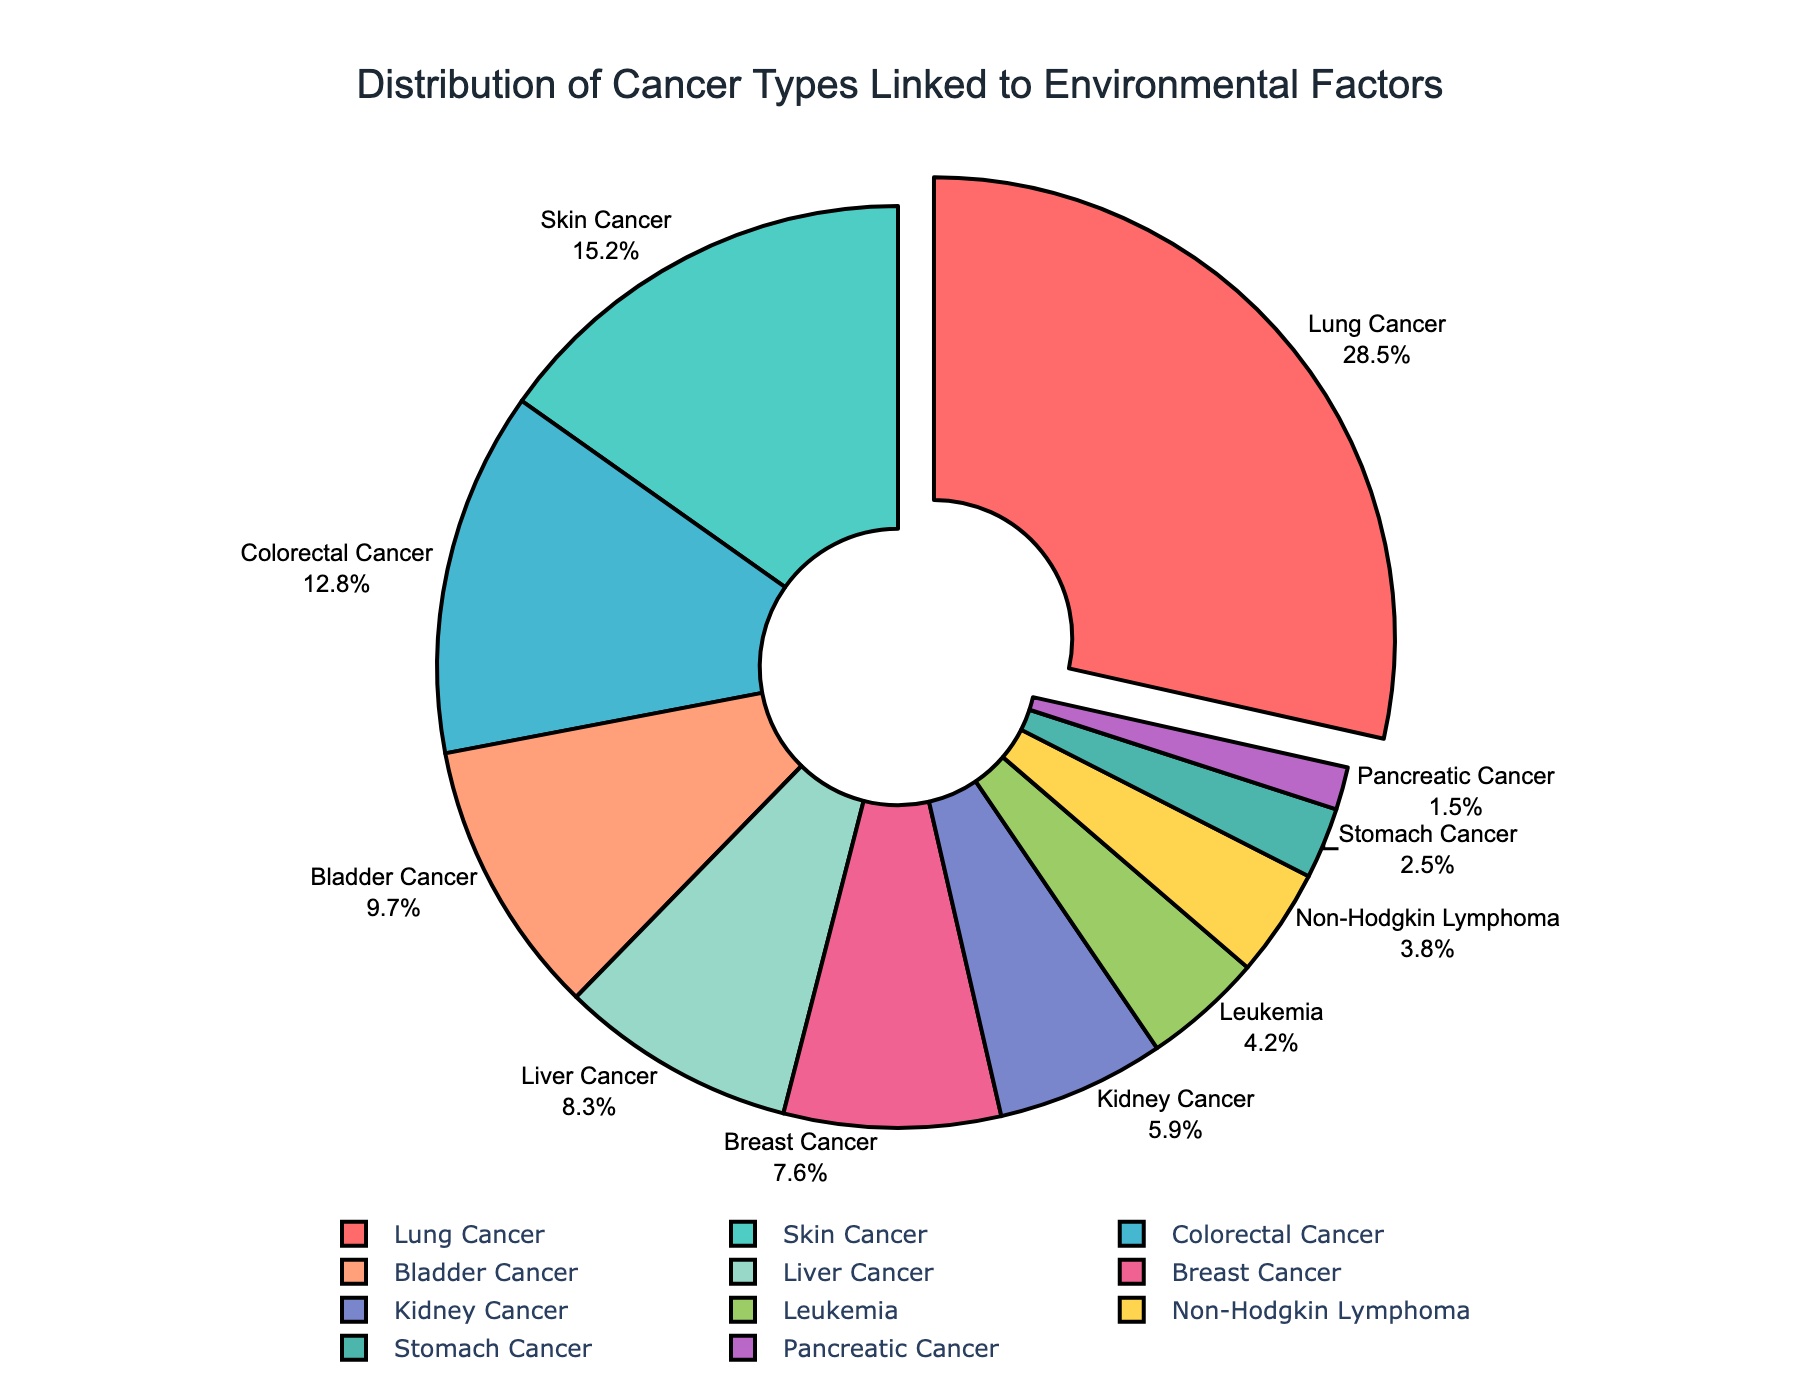What is the title of the pie chart? The title is displayed at the top center of the figure. It clearly states the purpose of the chart.
Answer: Distribution of Cancer Types Linked to Environmental Factors Which cancer type has the highest percentage? The largest segment of the pie chart, typically pulled out for emphasis, represents the highest percentage.
Answer: Lung Cancer How much percentage of the pie chart is attributed to Skin Cancer? Locate the segment labeled "Skin Cancer" and refer to the percentage indicated outside the segment.
Answer: 15.2% What is the combined percentage of Bladder Cancer and Liver Cancer? Find the percentages for Bladder Cancer and Liver Cancer, then sum them: 9.7% + 8.3%.
Answer: 18% Which cancer type has the smallest percentage? Identify the smallest segment of the pie chart and read its label.
Answer: Pancreatic Cancer How many cancer types have a percentage higher than 10%? Count the number of segments where the percentage exceeds 10%. These are Lung Cancer, Skin Cancer, and Colorectal Cancer.
Answer: 3 What is the difference in percentage between Breast Cancer and Kidney Cancer? Subtract the percentage of Kidney Cancer from that of Breast Cancer: 7.6% - 5.9%.
Answer: 1.7% Compare the percentages of Leukemia and Non-Hodgkin Lymphoma. Which is higher? Look at the segments for Leukemia and Non-Hodgkin Lymphoma and compare their percentages.
Answer: Leukemia What is the total percentage accounted for by Lung Cancer, Skin Cancer, and Colorectal Cancer? Add the percentages of the three cancer types: 28.5% + 15.2% + 12.8%.
Answer: 56.5% Is the percentage of Stomach Cancer greater than or less than 5%? Find the segment for Stomach Cancer and compare its percentage with 5%.
Answer: Less than 